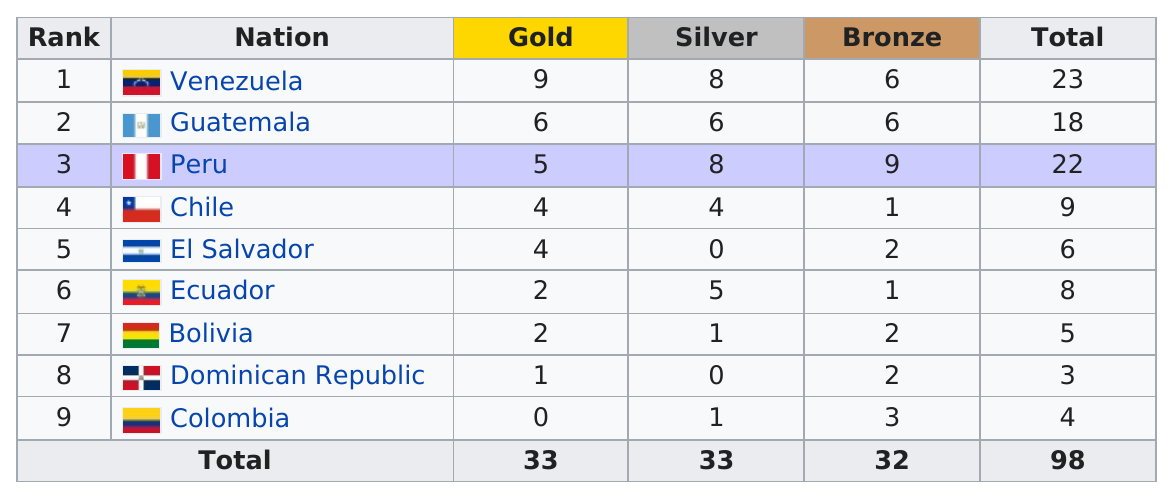Outline some significant characteristics in this image. Colombia received the least number of gold medals among all nations participating in the given event. Venezuela won more silvers than Chile did. El Salvador won two bronze medals. The Dominican Republic had the least overall number of medals among all counties. The total number of gold medals awarded is 33. 